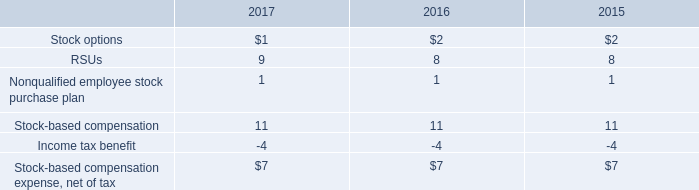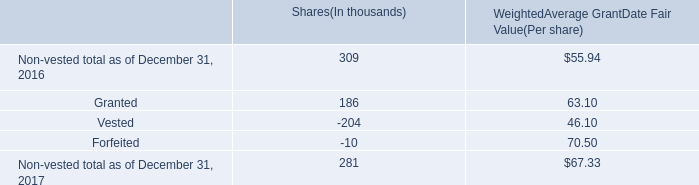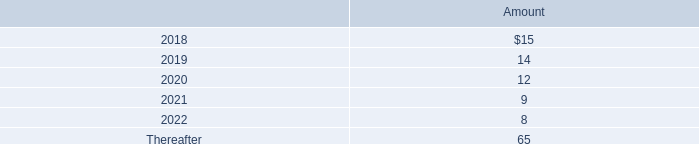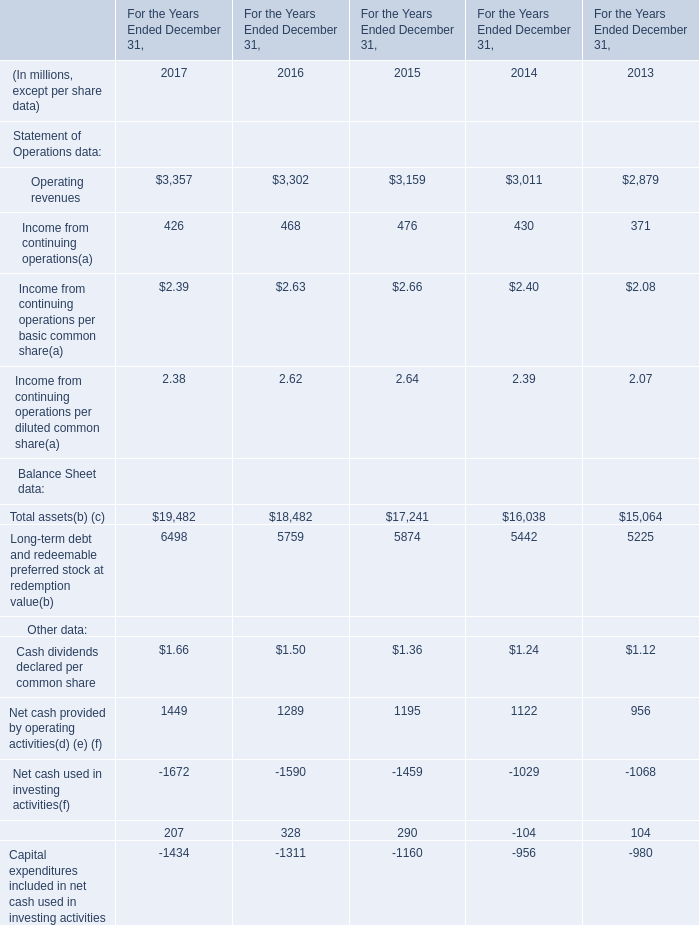What's the difference of Income from continuing operations(a)between 2016 and 2017? (in million) 
Computations: (468 - 426)
Answer: 42.0. 